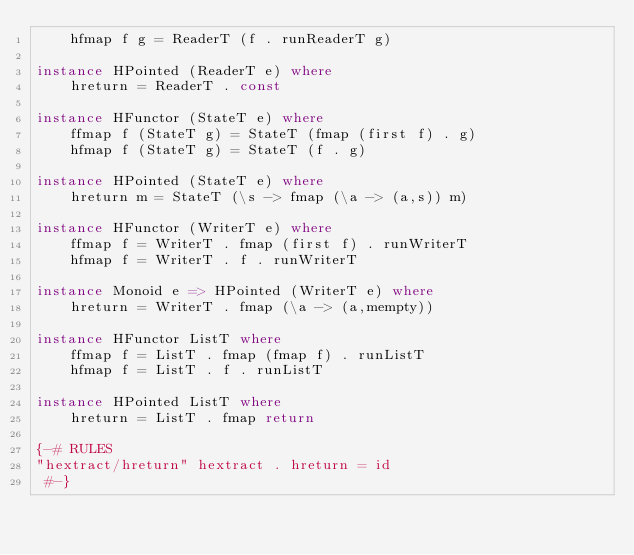Convert code to text. <code><loc_0><loc_0><loc_500><loc_500><_Haskell_>	hfmap f g = ReaderT (f . runReaderT g)

instance HPointed (ReaderT e) where
	hreturn = ReaderT . const

instance HFunctor (StateT e) where
	ffmap f (StateT g) = StateT (fmap (first f) . g)
	hfmap f (StateT g) = StateT (f . g)

instance HPointed (StateT e) where
	hreturn m = StateT (\s -> fmap (\a -> (a,s)) m) 

instance HFunctor (WriterT e) where
	ffmap f = WriterT . fmap (first f) . runWriterT 
	hfmap f = WriterT . f . runWriterT

instance Monoid e => HPointed (WriterT e) where
	hreturn = WriterT . fmap (\a -> (a,mempty))

instance HFunctor ListT where
	ffmap f = ListT . fmap (fmap f) . runListT 
	hfmap f = ListT . f . runListT

instance HPointed ListT where
	hreturn = ListT . fmap return

{-# RULES
"hextract/hreturn" hextract . hreturn = id
 #-}
</code> 